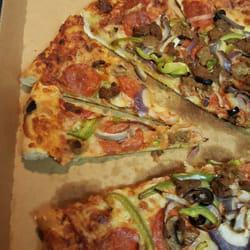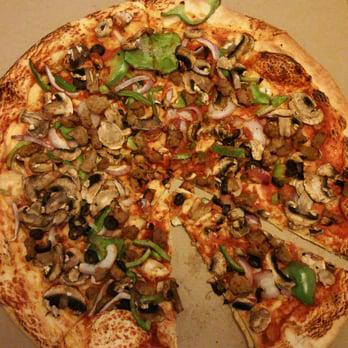The first image is the image on the left, the second image is the image on the right. Evaluate the accuracy of this statement regarding the images: "One image shows al least one pizza slice in a disposable plate and the other shows a full pizza in a brown cardboard box.". Is it true? Answer yes or no. No. The first image is the image on the left, the second image is the image on the right. Considering the images on both sides, is "The right image shows a whole sliced pizza in an open box, and the left image shows a triangular slice of pizza on a small round white plate." valid? Answer yes or no. No. 